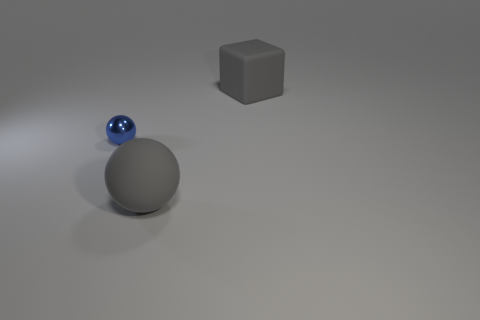Is there a large gray matte thing that has the same shape as the tiny blue metallic object?
Give a very brief answer. Yes. The tiny blue shiny thing has what shape?
Provide a succinct answer. Sphere. How many objects are either blue metallic spheres or large gray cubes?
Keep it short and to the point. 2. There is a gray object behind the large gray sphere; is it the same size as the sphere that is behind the large gray sphere?
Provide a succinct answer. No. How many other objects are there of the same material as the tiny ball?
Keep it short and to the point. 0. Is the number of large gray things that are in front of the large gray block greater than the number of gray matte blocks that are left of the gray matte sphere?
Ensure brevity in your answer.  Yes. What material is the ball to the left of the big rubber ball?
Your response must be concise. Metal. Is there any other thing of the same color as the large matte block?
Provide a succinct answer. Yes. The other matte thing that is the same shape as the tiny blue object is what color?
Make the answer very short. Gray. Is the number of gray spheres that are in front of the blue thing greater than the number of big purple rubber cylinders?
Your answer should be compact. Yes. 